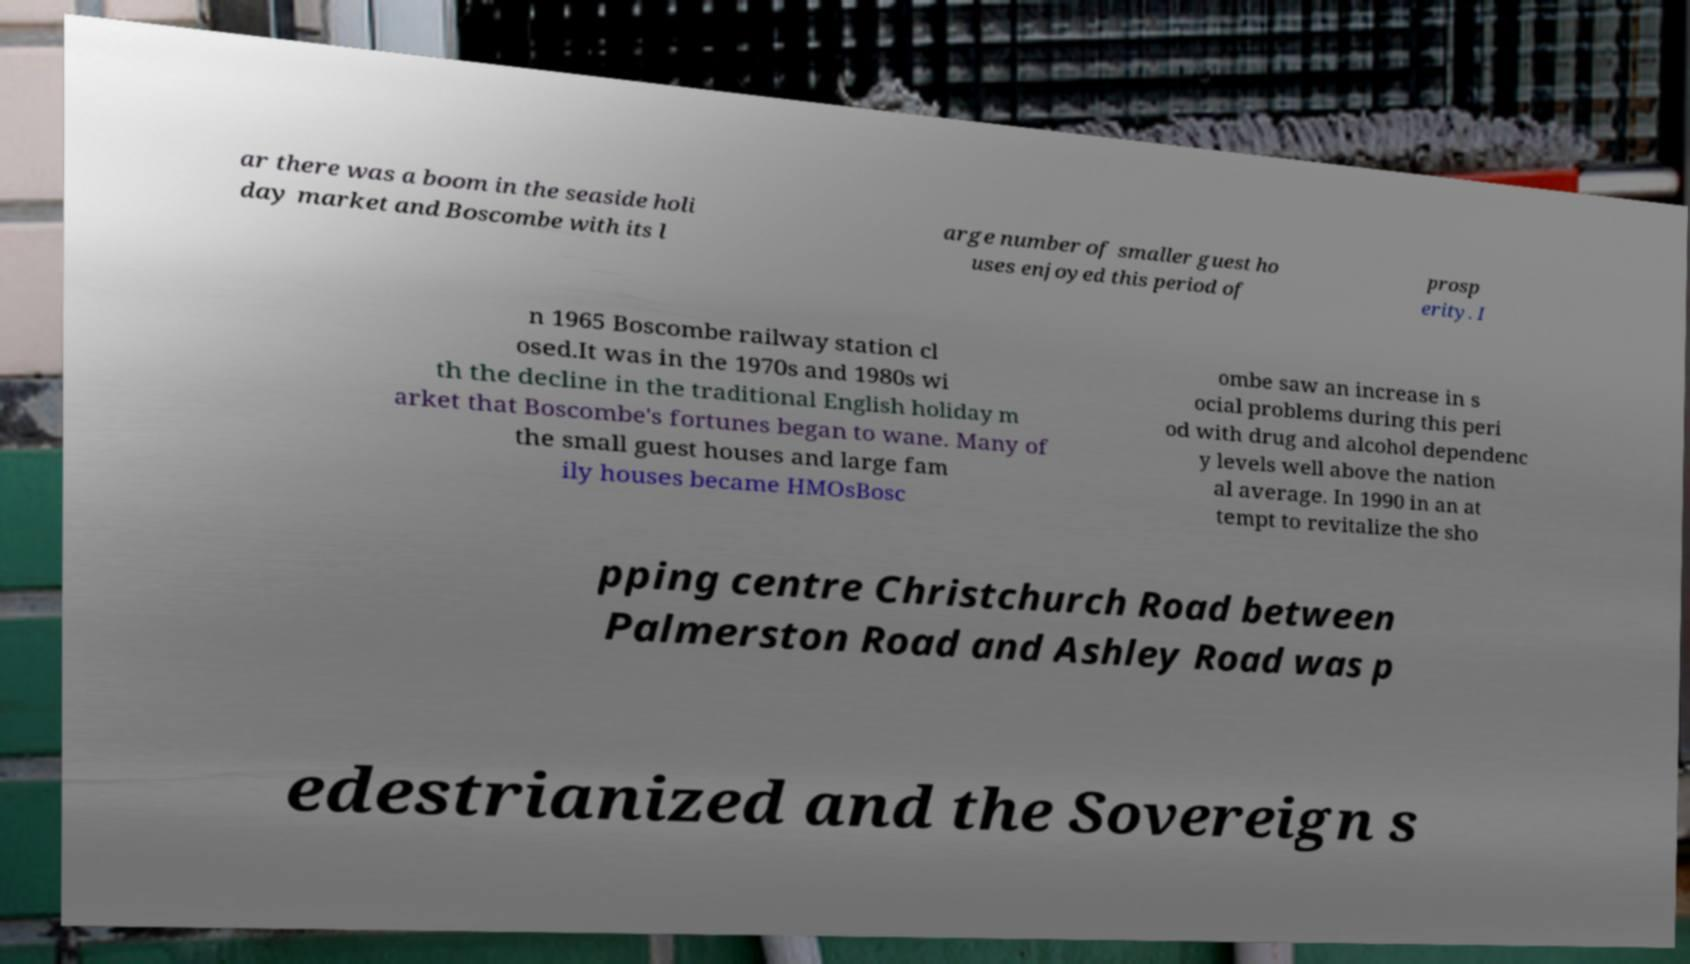Could you assist in decoding the text presented in this image and type it out clearly? ar there was a boom in the seaside holi day market and Boscombe with its l arge number of smaller guest ho uses enjoyed this period of prosp erity. I n 1965 Boscombe railway station cl osed.It was in the 1970s and 1980s wi th the decline in the traditional English holiday m arket that Boscombe's fortunes began to wane. Many of the small guest houses and large fam ily houses became HMOsBosc ombe saw an increase in s ocial problems during this peri od with drug and alcohol dependenc y levels well above the nation al average. In 1990 in an at tempt to revitalize the sho pping centre Christchurch Road between Palmerston Road and Ashley Road was p edestrianized and the Sovereign s 